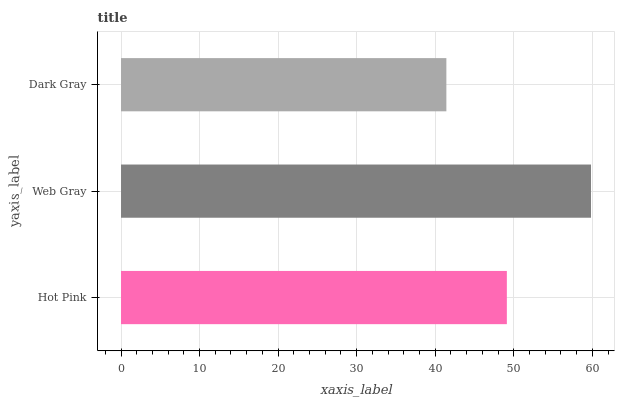Is Dark Gray the minimum?
Answer yes or no. Yes. Is Web Gray the maximum?
Answer yes or no. Yes. Is Web Gray the minimum?
Answer yes or no. No. Is Dark Gray the maximum?
Answer yes or no. No. Is Web Gray greater than Dark Gray?
Answer yes or no. Yes. Is Dark Gray less than Web Gray?
Answer yes or no. Yes. Is Dark Gray greater than Web Gray?
Answer yes or no. No. Is Web Gray less than Dark Gray?
Answer yes or no. No. Is Hot Pink the high median?
Answer yes or no. Yes. Is Hot Pink the low median?
Answer yes or no. Yes. Is Web Gray the high median?
Answer yes or no. No. Is Web Gray the low median?
Answer yes or no. No. 